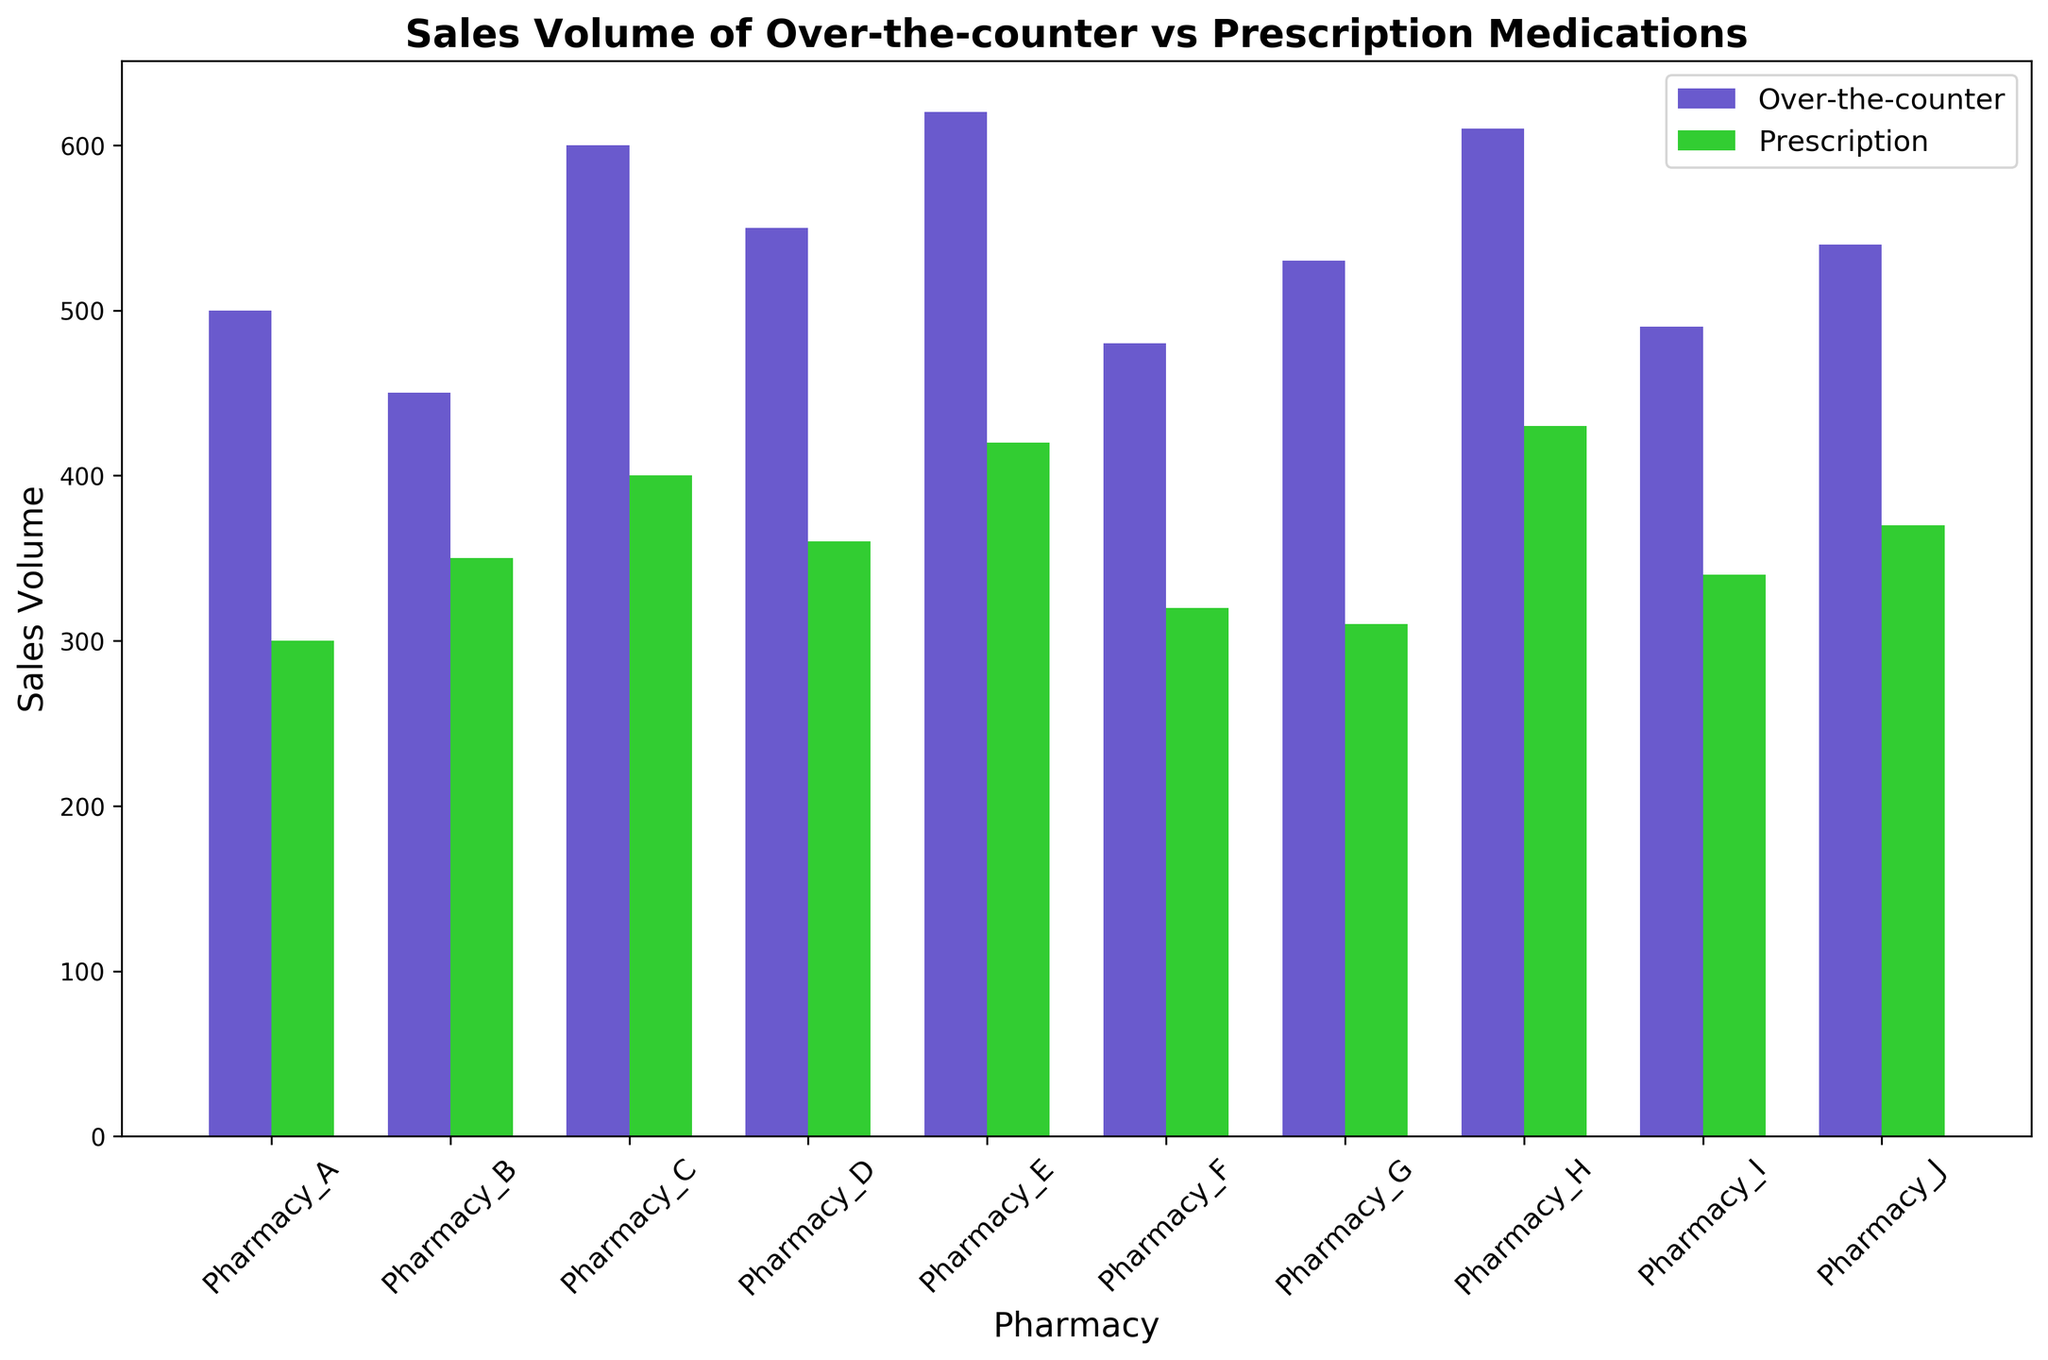Which pharmacy has the highest sales volume for over-the-counter medications? Look at the bar heights for over-the-counter medications; identify the tallest bar. Pharmacy_E has the highest sales volume.
Answer: Pharmacy_E What is the difference in sales volume between over-the-counter and prescription medications at Pharmacy_A? Subtract the sales volume of prescription medications from the sales volume of over-the-counter medications at Pharmacy_A: 500 - 300 = 200.
Answer: 200 Compare the sales volume of prescription medications between Pharmacy_D and Pharmacy_B. Which is higher? Compare the heights of the prescription medication bars for Pharmacy_D and Pharmacy_B. Pharmacy_B has a sales volume of 350, and Pharmacy_D has a sales volume of 360. 360 is higher than 350.
Answer: Pharmacy_D What is the average sales volume of prescription medications across all pharmacies? Sum the sales volumes of prescription medications from all pharmacies and divide by the number of pharmacies: (300+350+400+360+420+320+310+430+340+370)/10 = 400.
Answer: 400 Which type of medication has a higher total sales volume at Pharmacy_H? Compare the bar heights of over-the-counter and prescription medications at Pharmacy_H. Over-the-counter has a sales volume of 610 and prescription has a sales volume of 430. 610 is higher than 430.
Answer: Over-the-counter What is the total sales volume of over-the-counter medications for Pharmacy_C and Pharmacy_F combined? Add the sales volumes of over-the-counter medications from Pharmacy_C and Pharmacy_F: 600 + 480 = 1080.
Answer: 1080 